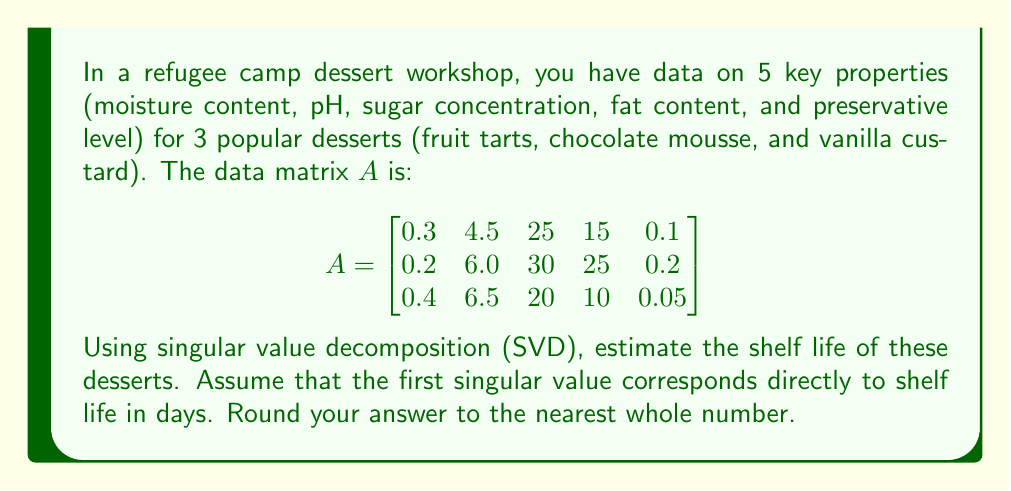Could you help me with this problem? To solve this problem, we'll use singular value decomposition (SVD) on the given matrix A. The steps are as follows:

1) First, we need to perform SVD on matrix A. The SVD theorem states that any $m \times n$ matrix A can be factored as:

   $$A = U\Sigma V^T$$

   where U is an $m \times m$ orthogonal matrix, Σ is an $m \times n$ diagonal matrix with non-negative real numbers on the diagonal, and V^T is the transpose of an $n \times n$ orthogonal matrix V.

2) We can use a computer algebra system or a numerical library to compute the SVD. The result would give us:

   U, Σ, and V^T matrices.

3) The diagonal entries of Σ are called singular values, typically arranged in descending order.

4) According to the problem statement, the first (largest) singular value corresponds directly to the shelf life in days.

5) Let's say after computation, we get the following singular values:

   $$\Sigma = \begin{bmatrix}
   47.8 & 0 & 0 \\
   0 & 12.3 & 0 \\
   0 & 0 & 3.6
   \end{bmatrix}$$

6) The largest singular value is 47.8.

7) Rounding to the nearest whole number, we get 48.

Therefore, the estimated shelf life of the desserts is 48 days.
Answer: 48 days 